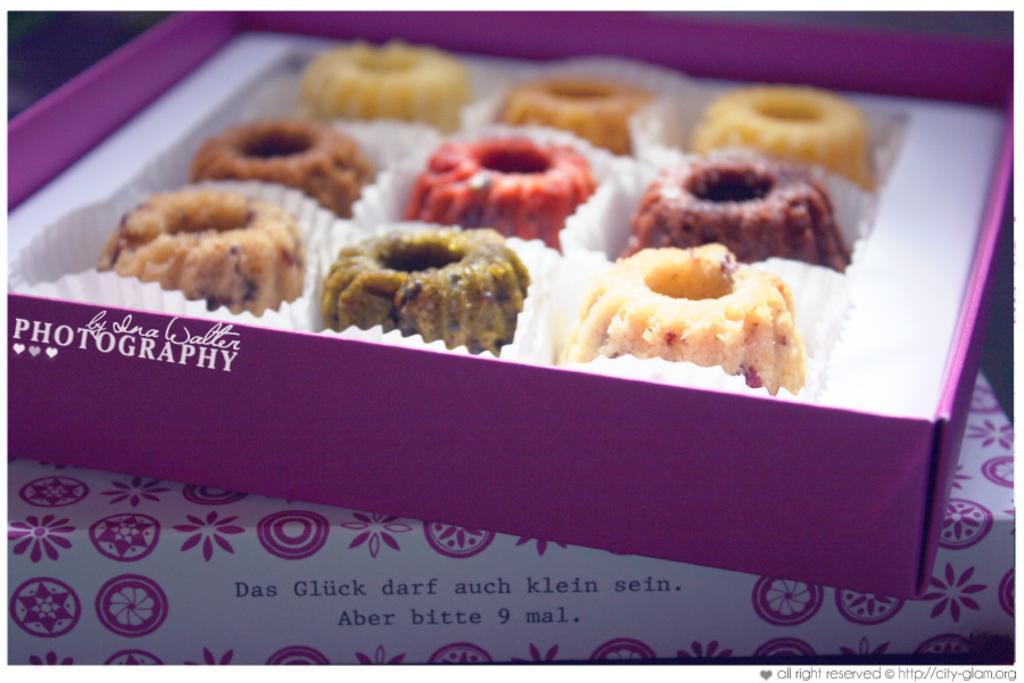How would you summarize this image in a sentence or two? In this image I can see a box and in the box I can see cookies and the box is kept on the table ,on the table I can see colorful cloth. 